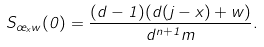<formula> <loc_0><loc_0><loc_500><loc_500>S _ { \sigma _ { x } w } ( 0 ) = \frac { ( d - 1 ) ( d ( j - x ) + w ) } { d ^ { n + 1 } m } .</formula> 